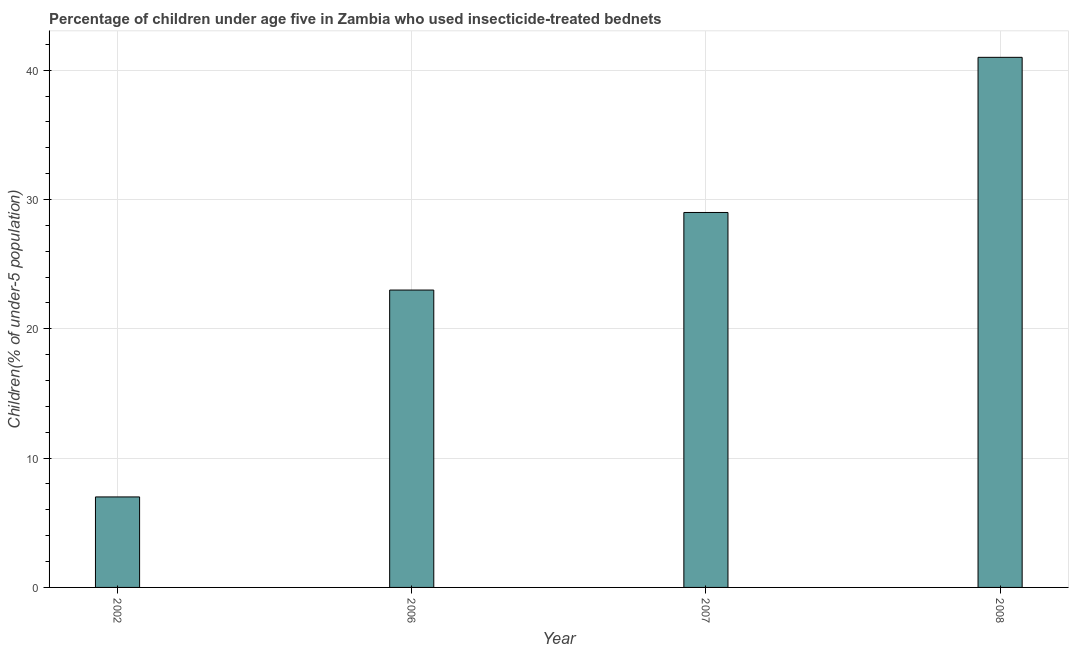Does the graph contain any zero values?
Provide a short and direct response. No. What is the title of the graph?
Your answer should be very brief. Percentage of children under age five in Zambia who used insecticide-treated bednets. What is the label or title of the X-axis?
Make the answer very short. Year. What is the label or title of the Y-axis?
Make the answer very short. Children(% of under-5 population). What is the percentage of children who use of insecticide-treated bed nets in 2006?
Your response must be concise. 23. Across all years, what is the maximum percentage of children who use of insecticide-treated bed nets?
Your response must be concise. 41. In which year was the percentage of children who use of insecticide-treated bed nets minimum?
Give a very brief answer. 2002. What is the sum of the percentage of children who use of insecticide-treated bed nets?
Give a very brief answer. 100. What is the difference between the percentage of children who use of insecticide-treated bed nets in 2006 and 2008?
Give a very brief answer. -18. What is the average percentage of children who use of insecticide-treated bed nets per year?
Offer a terse response. 25. What is the median percentage of children who use of insecticide-treated bed nets?
Offer a very short reply. 26. What is the ratio of the percentage of children who use of insecticide-treated bed nets in 2006 to that in 2007?
Provide a succinct answer. 0.79. Is the percentage of children who use of insecticide-treated bed nets in 2002 less than that in 2006?
Your answer should be very brief. Yes. Is the difference between the percentage of children who use of insecticide-treated bed nets in 2006 and 2008 greater than the difference between any two years?
Offer a terse response. No. What is the difference between the highest and the second highest percentage of children who use of insecticide-treated bed nets?
Provide a succinct answer. 12. Is the sum of the percentage of children who use of insecticide-treated bed nets in 2002 and 2006 greater than the maximum percentage of children who use of insecticide-treated bed nets across all years?
Provide a succinct answer. No. What is the difference between the highest and the lowest percentage of children who use of insecticide-treated bed nets?
Provide a succinct answer. 34. In how many years, is the percentage of children who use of insecticide-treated bed nets greater than the average percentage of children who use of insecticide-treated bed nets taken over all years?
Ensure brevity in your answer.  2. How many years are there in the graph?
Provide a succinct answer. 4. What is the difference between the Children(% of under-5 population) in 2002 and 2008?
Keep it short and to the point. -34. What is the difference between the Children(% of under-5 population) in 2006 and 2007?
Ensure brevity in your answer.  -6. What is the ratio of the Children(% of under-5 population) in 2002 to that in 2006?
Your answer should be very brief. 0.3. What is the ratio of the Children(% of under-5 population) in 2002 to that in 2007?
Provide a short and direct response. 0.24. What is the ratio of the Children(% of under-5 population) in 2002 to that in 2008?
Your response must be concise. 0.17. What is the ratio of the Children(% of under-5 population) in 2006 to that in 2007?
Offer a terse response. 0.79. What is the ratio of the Children(% of under-5 population) in 2006 to that in 2008?
Provide a succinct answer. 0.56. What is the ratio of the Children(% of under-5 population) in 2007 to that in 2008?
Provide a succinct answer. 0.71. 